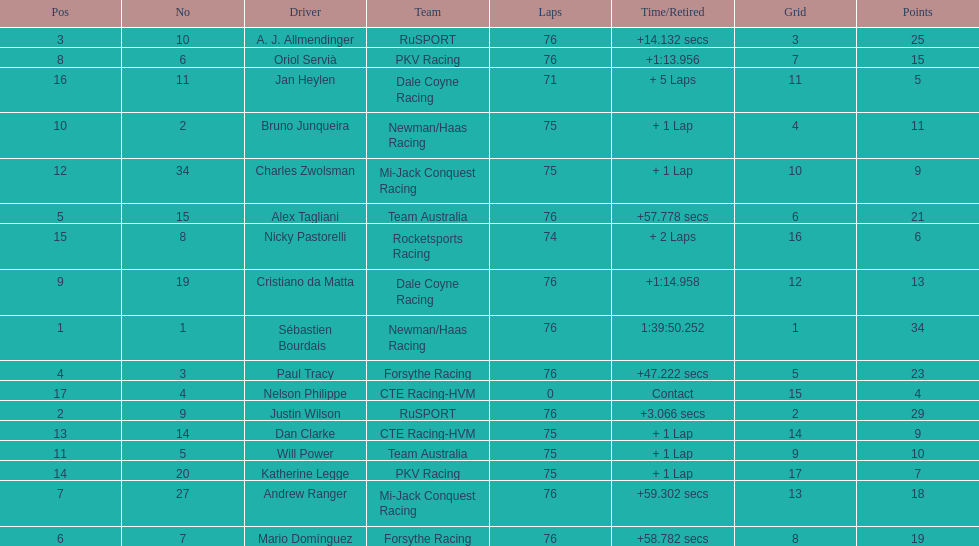Which driver has the least amount of points? Nelson Philippe. 